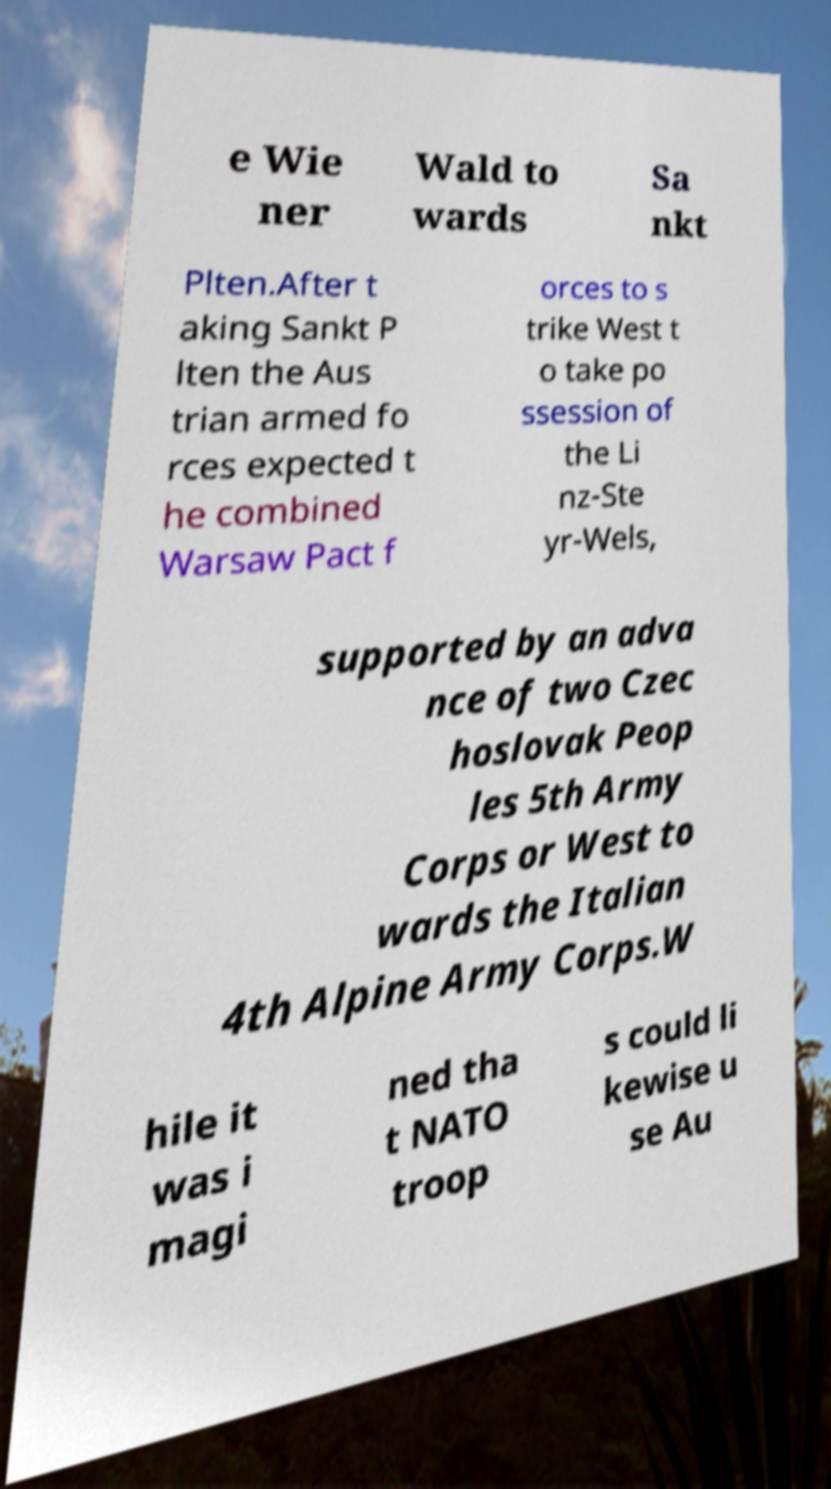What messages or text are displayed in this image? I need them in a readable, typed format. e Wie ner Wald to wards Sa nkt Plten.After t aking Sankt P lten the Aus trian armed fo rces expected t he combined Warsaw Pact f orces to s trike West t o take po ssession of the Li nz-Ste yr-Wels, supported by an adva nce of two Czec hoslovak Peop les 5th Army Corps or West to wards the Italian 4th Alpine Army Corps.W hile it was i magi ned tha t NATO troop s could li kewise u se Au 